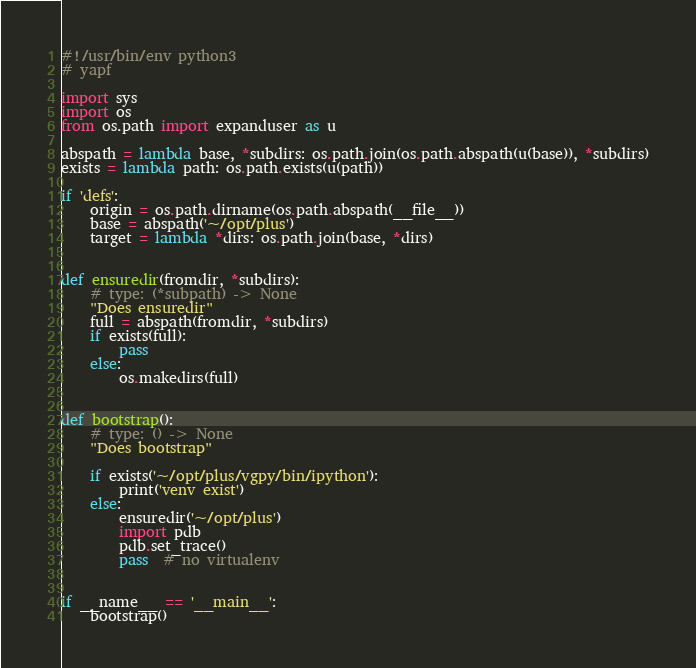Convert code to text. <code><loc_0><loc_0><loc_500><loc_500><_Python_>#!/usr/bin/env python3
# yapf

import sys
import os
from os.path import expanduser as u

abspath = lambda base, *subdirs: os.path.join(os.path.abspath(u(base)), *subdirs)
exists = lambda path: os.path.exists(u(path))

if 'defs':
    origin = os.path.dirname(os.path.abspath(__file__))
    base = abspath('~/opt/plus')
    target = lambda *dirs: os.path.join(base, *dirs)


def ensuredir(fromdir, *subdirs):
    # type: (*subpath) -> None
    "Does ensuredir"
    full = abspath(fromdir, *subdirs)
    if exists(full):
        pass
    else:
        os.makedirs(full)


def bootstrap():
    # type: () -> None
    "Does bootstrap"

    if exists('~/opt/plus/vgpy/bin/ipython'):
        print('venv exist')
    else:
        ensuredir('~/opt/plus')
        import pdb
        pdb.set_trace()
        pass  # no virtualenv


if __name__ == '__main__':
    bootstrap()
</code> 